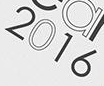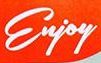Transcribe the words shown in these images in order, separated by a semicolon. 2016; Enjoy 